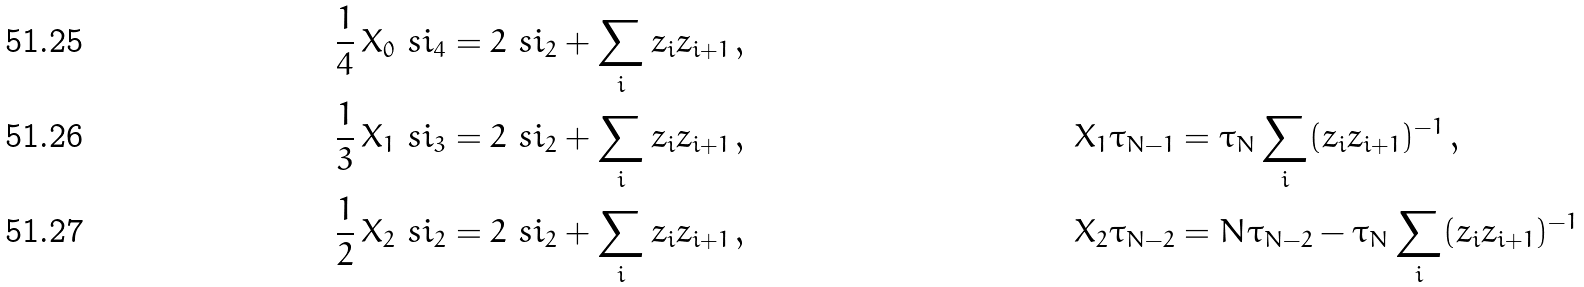<formula> <loc_0><loc_0><loc_500><loc_500>\frac { 1 } { 4 } \, X _ { 0 } \ s i _ { 4 } & = 2 \ s i _ { 2 } + \sum _ { i } z _ { i } z _ { i + 1 } \, , \\ \frac { 1 } { 3 } \, X _ { 1 } \ s i _ { 3 } & = 2 \ s i _ { 2 } + \sum _ { i } z _ { i } z _ { i + 1 } \, , & X _ { 1 } \tau _ { N - 1 } & = \tau _ { N } \sum _ { i } ( { z _ { i } z _ { i + 1 } } ) ^ { - 1 } \, , \\ \frac { 1 } { 2 } \, X _ { 2 } \ s i _ { 2 } & = 2 \ s i _ { 2 } + \sum _ { i } z _ { i } z _ { i + 1 } \, , & X _ { 2 } \tau _ { N - 2 } & = N \tau _ { N - 2 } - \tau _ { N } \sum _ { i } ( z _ { i } z _ { i + 1 } ) ^ { - 1 }</formula> 